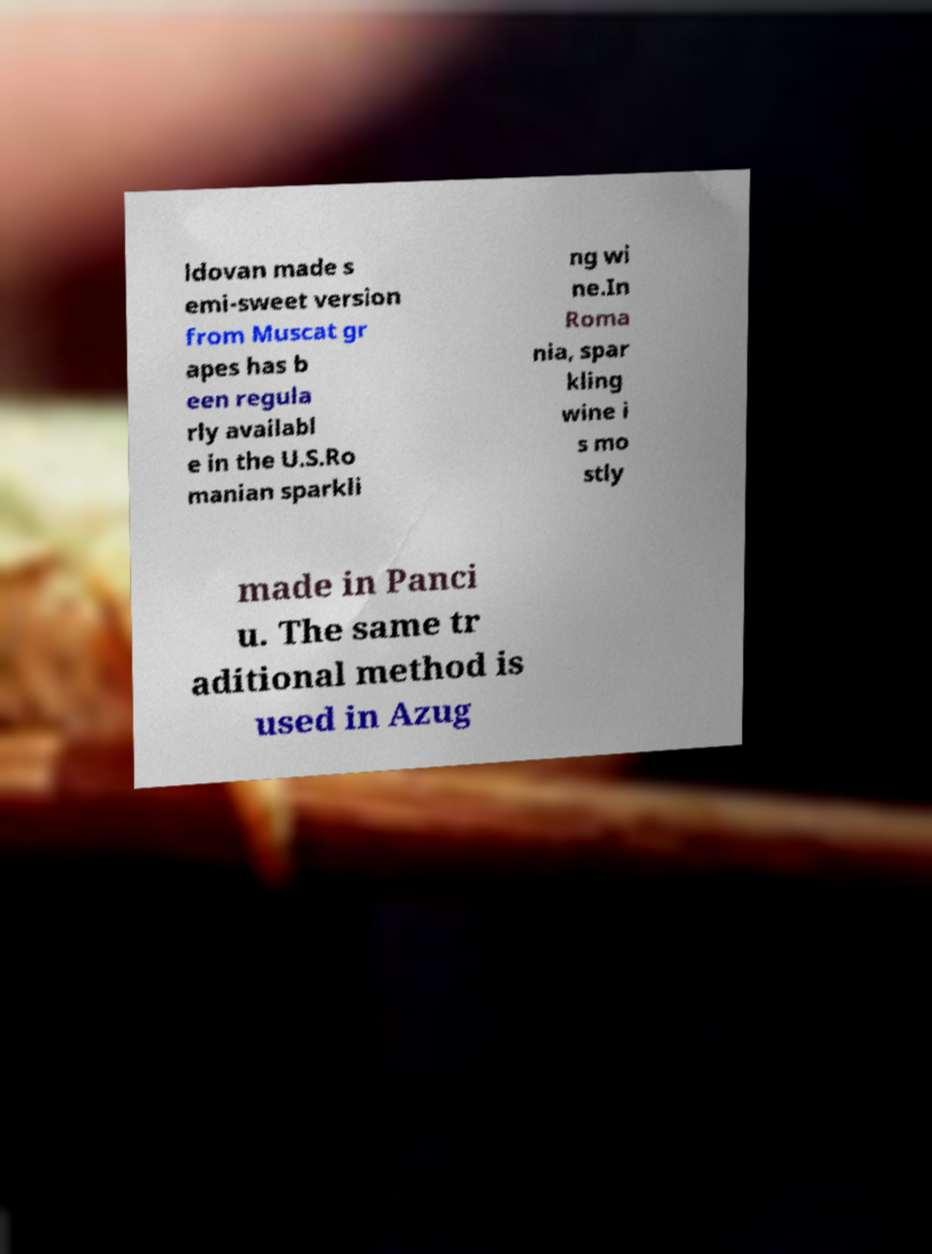Can you accurately transcribe the text from the provided image for me? ldovan made s emi-sweet version from Muscat gr apes has b een regula rly availabl e in the U.S.Ro manian sparkli ng wi ne.In Roma nia, spar kling wine i s mo stly made in Panci u. The same tr aditional method is used in Azug 